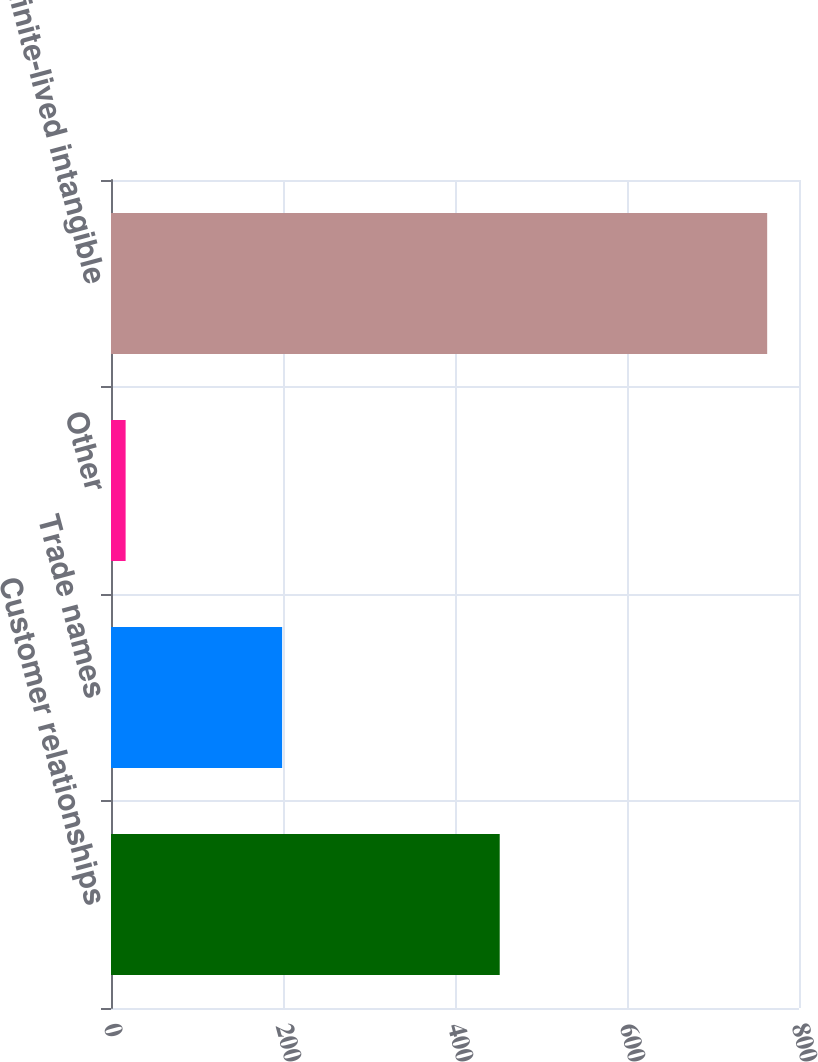Convert chart. <chart><loc_0><loc_0><loc_500><loc_500><bar_chart><fcel>Customer relationships<fcel>Trade names<fcel>Other<fcel>Total finite-lived intangible<nl><fcel>452<fcel>199<fcel>17<fcel>763<nl></chart> 